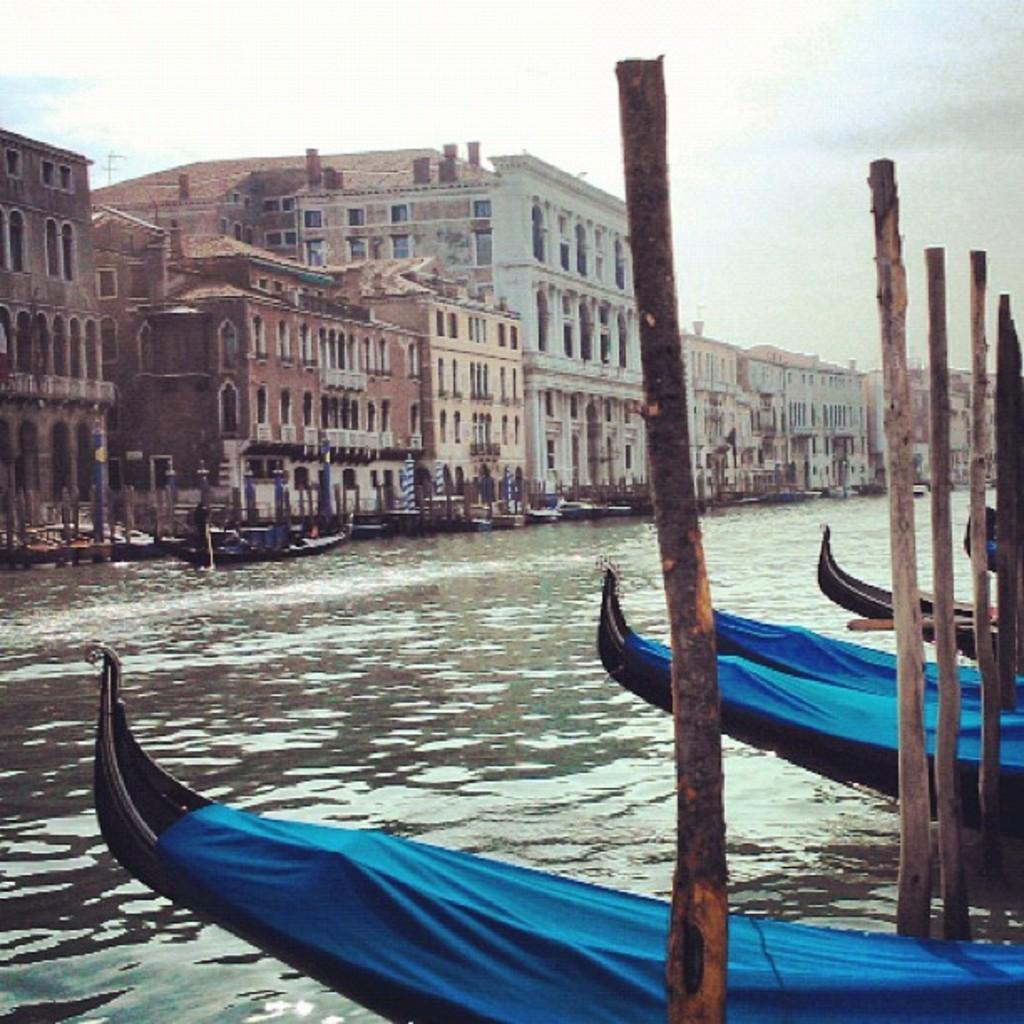Can you describe this image briefly? In the image in the center, we can see poles, boats and water. On the boats, we can see blue curtain. In the background we can see the sky, clouds, buildings, boats etc. 